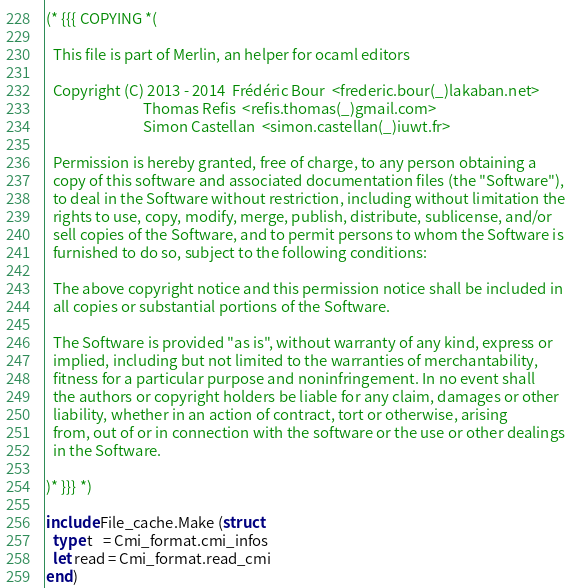<code> <loc_0><loc_0><loc_500><loc_500><_OCaml_>(* {{{ COPYING *(

  This file is part of Merlin, an helper for ocaml editors

  Copyright (C) 2013 - 2014  Frédéric Bour  <frederic.bour(_)lakaban.net>
                             Thomas Refis  <refis.thomas(_)gmail.com>
                             Simon Castellan  <simon.castellan(_)iuwt.fr>

  Permission is hereby granted, free of charge, to any person obtaining a
  copy of this software and associated documentation files (the "Software"),
  to deal in the Software without restriction, including without limitation the
  rights to use, copy, modify, merge, publish, distribute, sublicense, and/or
  sell copies of the Software, and to permit persons to whom the Software is
  furnished to do so, subject to the following conditions:

  The above copyright notice and this permission notice shall be included in
  all copies or substantial portions of the Software.

  The Software is provided "as is", without warranty of any kind, express or
  implied, including but not limited to the warranties of merchantability,
  fitness for a particular purpose and noninfringement. In no event shall
  the authors or copyright holders be liable for any claim, damages or other
  liability, whether in an action of contract, tort or otherwise, arising
  from, out of or in connection with the software or the use or other dealings
  in the Software.

)* }}} *)

include File_cache.Make (struct
  type t   = Cmi_format.cmi_infos
  let read = Cmi_format.read_cmi
end)
</code> 